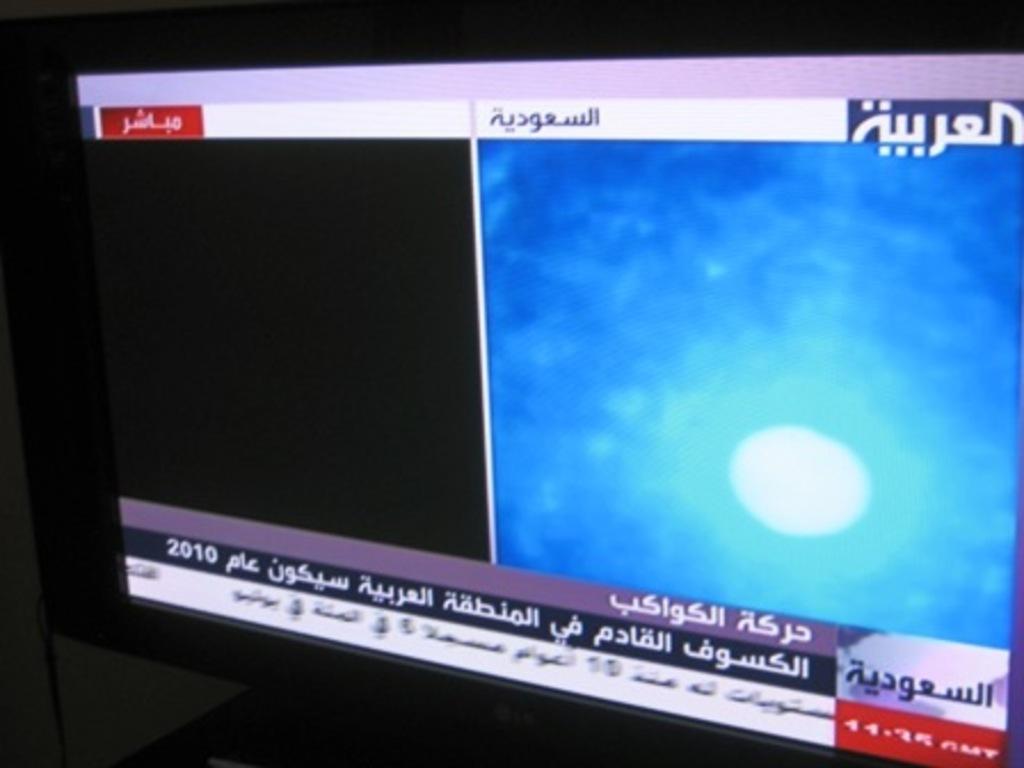What year is shown on the screen?
Ensure brevity in your answer.  2010. 